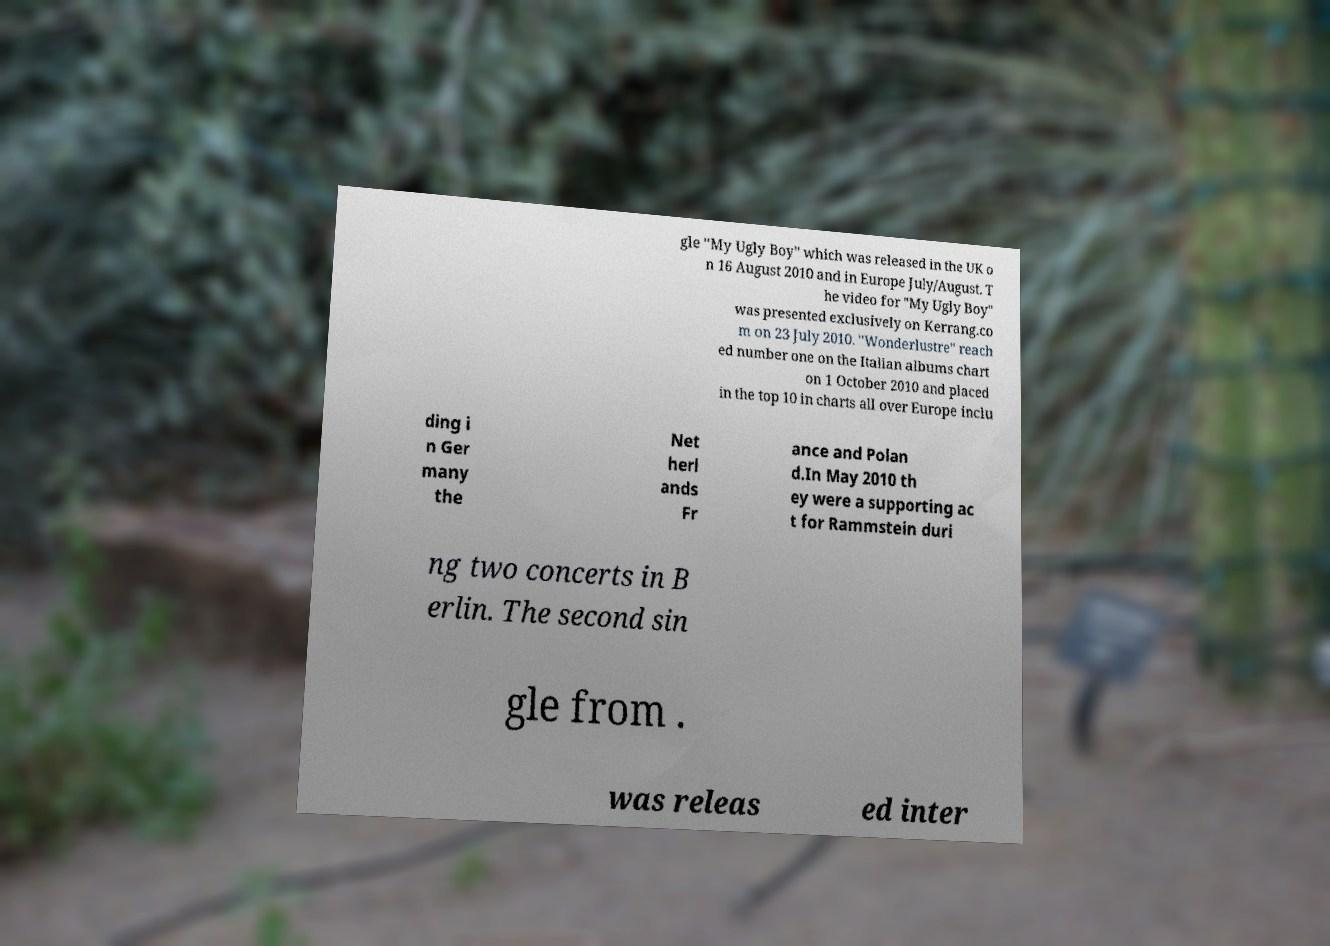Can you accurately transcribe the text from the provided image for me? gle "My Ugly Boy" which was released in the UK o n 16 August 2010 and in Europe July/August. T he video for "My Ugly Boy" was presented exclusively on Kerrang.co m on 23 July 2010. "Wonderlustre" reach ed number one on the Italian albums chart on 1 October 2010 and placed in the top 10 in charts all over Europe inclu ding i n Ger many the Net herl ands Fr ance and Polan d.In May 2010 th ey were a supporting ac t for Rammstein duri ng two concerts in B erlin. The second sin gle from . was releas ed inter 